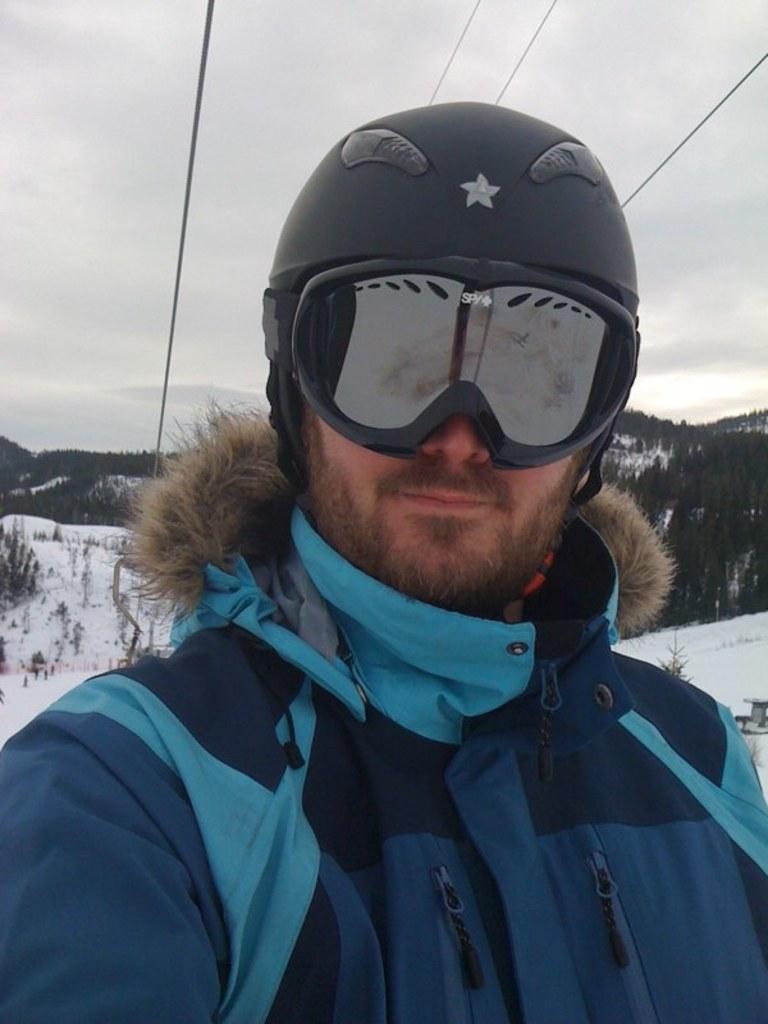Please provide a concise description of this image. In the center of the image we can see a person with a helmet and glasses. In the background we can see many trees. Snow is also visible. There is a cloudy sky. 